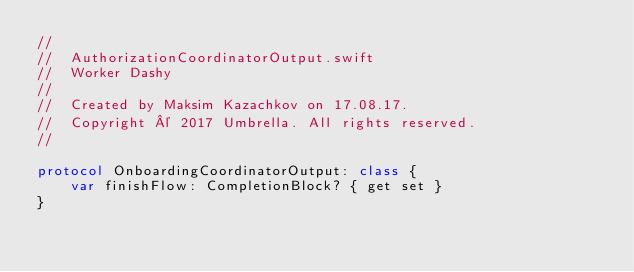<code> <loc_0><loc_0><loc_500><loc_500><_Swift_>//
//  AuthorizationCoordinatorOutput.swift
//  Worker Dashy
//
//  Created by Maksim Kazachkov on 17.08.17.
//  Copyright © 2017 Umbrella. All rights reserved.
//

protocol OnboardingCoordinatorOutput: class {
    var finishFlow: CompletionBlock? { get set }
}
</code> 